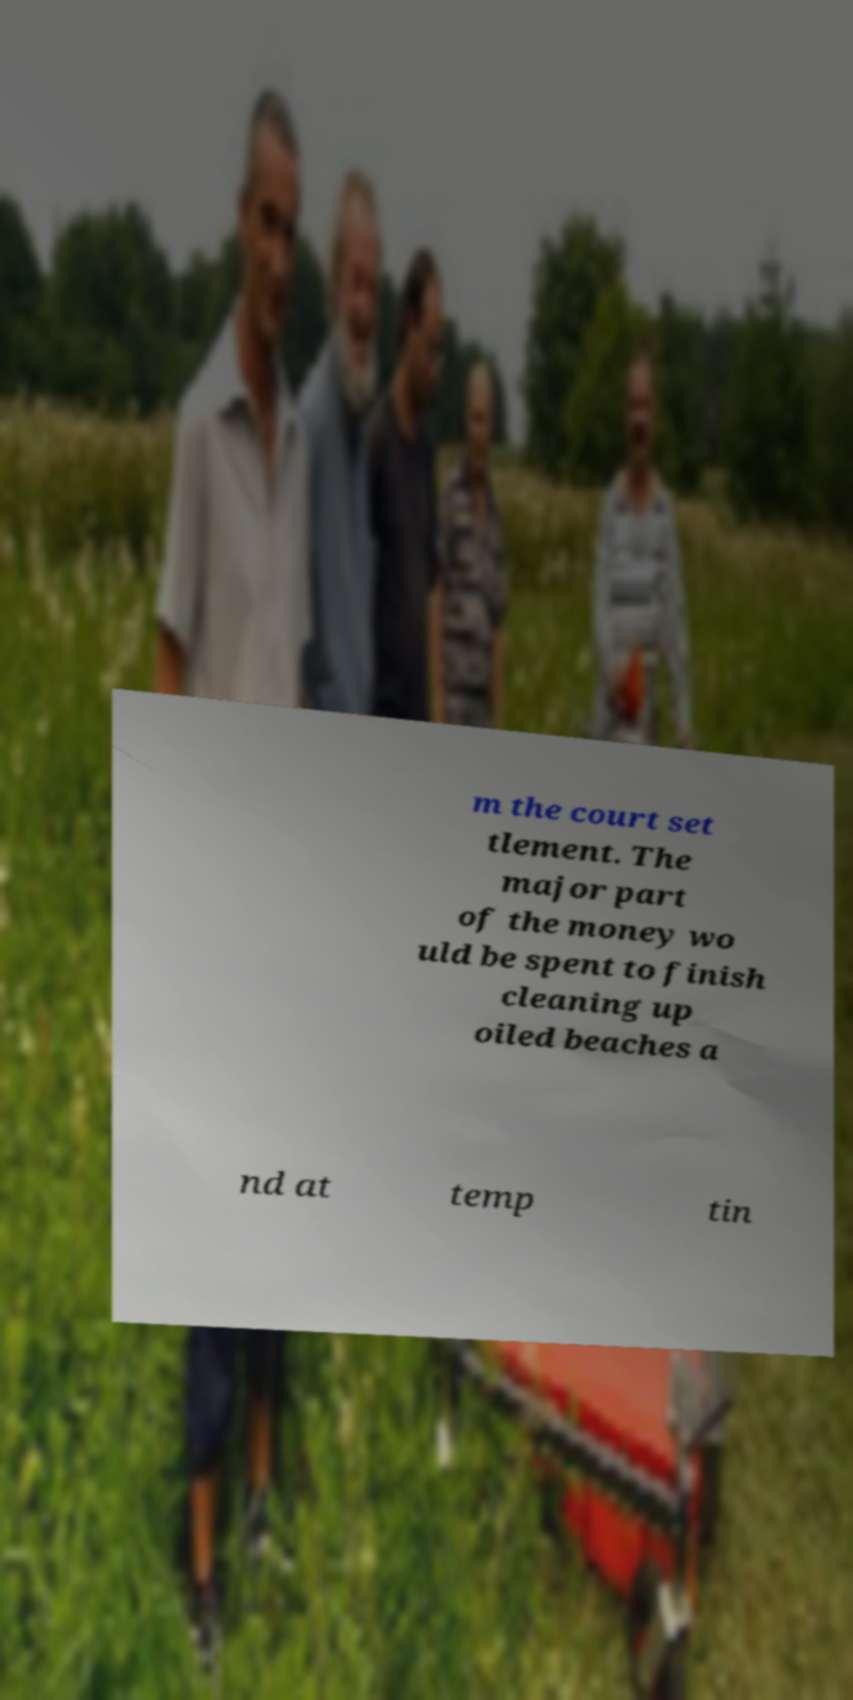Could you assist in decoding the text presented in this image and type it out clearly? m the court set tlement. The major part of the money wo uld be spent to finish cleaning up oiled beaches a nd at temp tin 